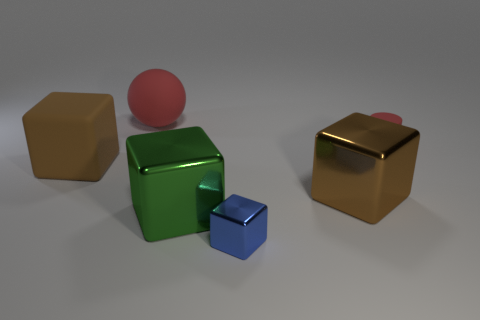Subtract all large blocks. How many blocks are left? 1 Subtract 4 cubes. How many cubes are left? 0 Subtract all brown cubes. How many cubes are left? 2 Add 2 green metal cubes. How many objects exist? 8 Add 5 large matte spheres. How many large matte spheres are left? 6 Add 2 blue metal objects. How many blue metal objects exist? 3 Subtract 0 yellow cylinders. How many objects are left? 6 Subtract all cylinders. How many objects are left? 5 Subtract all yellow blocks. Subtract all brown cylinders. How many blocks are left? 4 Subtract all purple spheres. How many brown blocks are left? 2 